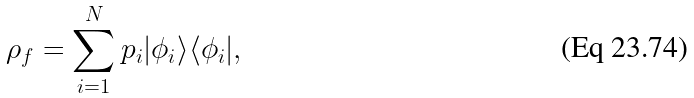Convert formula to latex. <formula><loc_0><loc_0><loc_500><loc_500>\rho _ { f } = \sum _ { i = 1 } ^ { N } p _ { i } | \phi _ { i } \rangle \langle \phi _ { i } | ,</formula> 